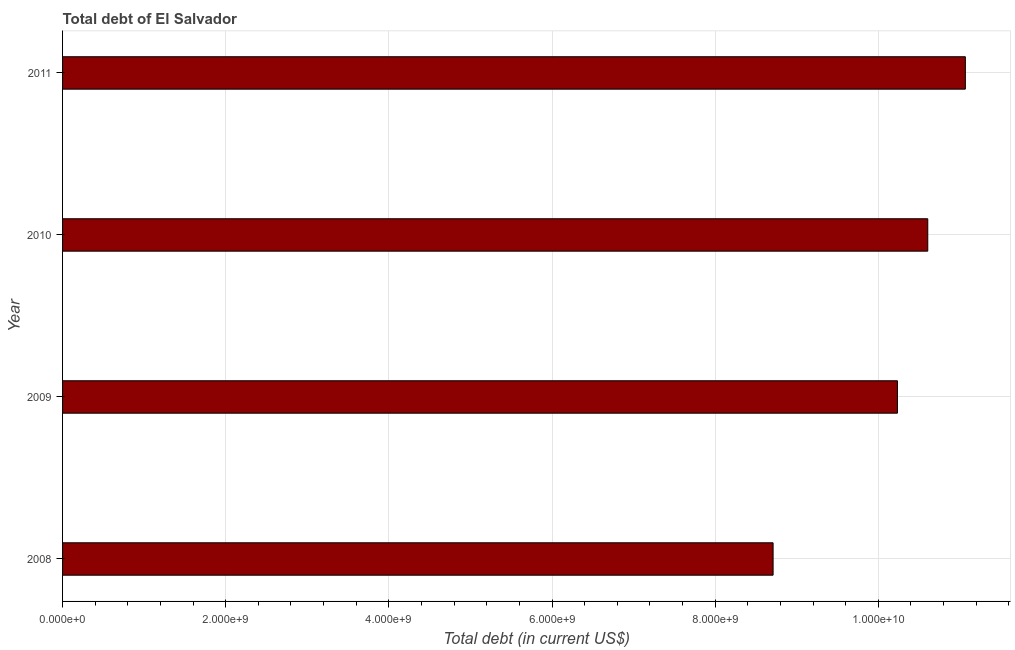What is the title of the graph?
Offer a terse response. Total debt of El Salvador. What is the label or title of the X-axis?
Ensure brevity in your answer.  Total debt (in current US$). What is the total debt in 2010?
Offer a terse response. 1.06e+1. Across all years, what is the maximum total debt?
Make the answer very short. 1.11e+1. Across all years, what is the minimum total debt?
Your answer should be very brief. 8.71e+09. In which year was the total debt maximum?
Make the answer very short. 2011. What is the sum of the total debt?
Give a very brief answer. 4.06e+1. What is the difference between the total debt in 2008 and 2009?
Your answer should be compact. -1.52e+09. What is the average total debt per year?
Give a very brief answer. 1.02e+1. What is the median total debt?
Your response must be concise. 1.04e+1. In how many years, is the total debt greater than 2400000000 US$?
Offer a very short reply. 4. Do a majority of the years between 2009 and 2011 (inclusive) have total debt greater than 8400000000 US$?
Offer a terse response. Yes. Is the total debt in 2009 less than that in 2010?
Offer a terse response. Yes. What is the difference between the highest and the second highest total debt?
Offer a very short reply. 4.61e+08. What is the difference between the highest and the lowest total debt?
Provide a short and direct response. 2.36e+09. Are all the bars in the graph horizontal?
Provide a succinct answer. Yes. How many years are there in the graph?
Your answer should be compact. 4. What is the Total debt (in current US$) in 2008?
Your answer should be very brief. 8.71e+09. What is the Total debt (in current US$) of 2009?
Offer a very short reply. 1.02e+1. What is the Total debt (in current US$) in 2010?
Provide a succinct answer. 1.06e+1. What is the Total debt (in current US$) of 2011?
Your response must be concise. 1.11e+1. What is the difference between the Total debt (in current US$) in 2008 and 2009?
Provide a short and direct response. -1.52e+09. What is the difference between the Total debt (in current US$) in 2008 and 2010?
Your answer should be very brief. -1.90e+09. What is the difference between the Total debt (in current US$) in 2008 and 2011?
Offer a terse response. -2.36e+09. What is the difference between the Total debt (in current US$) in 2009 and 2010?
Provide a succinct answer. -3.72e+08. What is the difference between the Total debt (in current US$) in 2009 and 2011?
Make the answer very short. -8.33e+08. What is the difference between the Total debt (in current US$) in 2010 and 2011?
Make the answer very short. -4.61e+08. What is the ratio of the Total debt (in current US$) in 2008 to that in 2009?
Provide a succinct answer. 0.85. What is the ratio of the Total debt (in current US$) in 2008 to that in 2010?
Make the answer very short. 0.82. What is the ratio of the Total debt (in current US$) in 2008 to that in 2011?
Offer a terse response. 0.79. What is the ratio of the Total debt (in current US$) in 2009 to that in 2011?
Ensure brevity in your answer.  0.93. What is the ratio of the Total debt (in current US$) in 2010 to that in 2011?
Offer a very short reply. 0.96. 